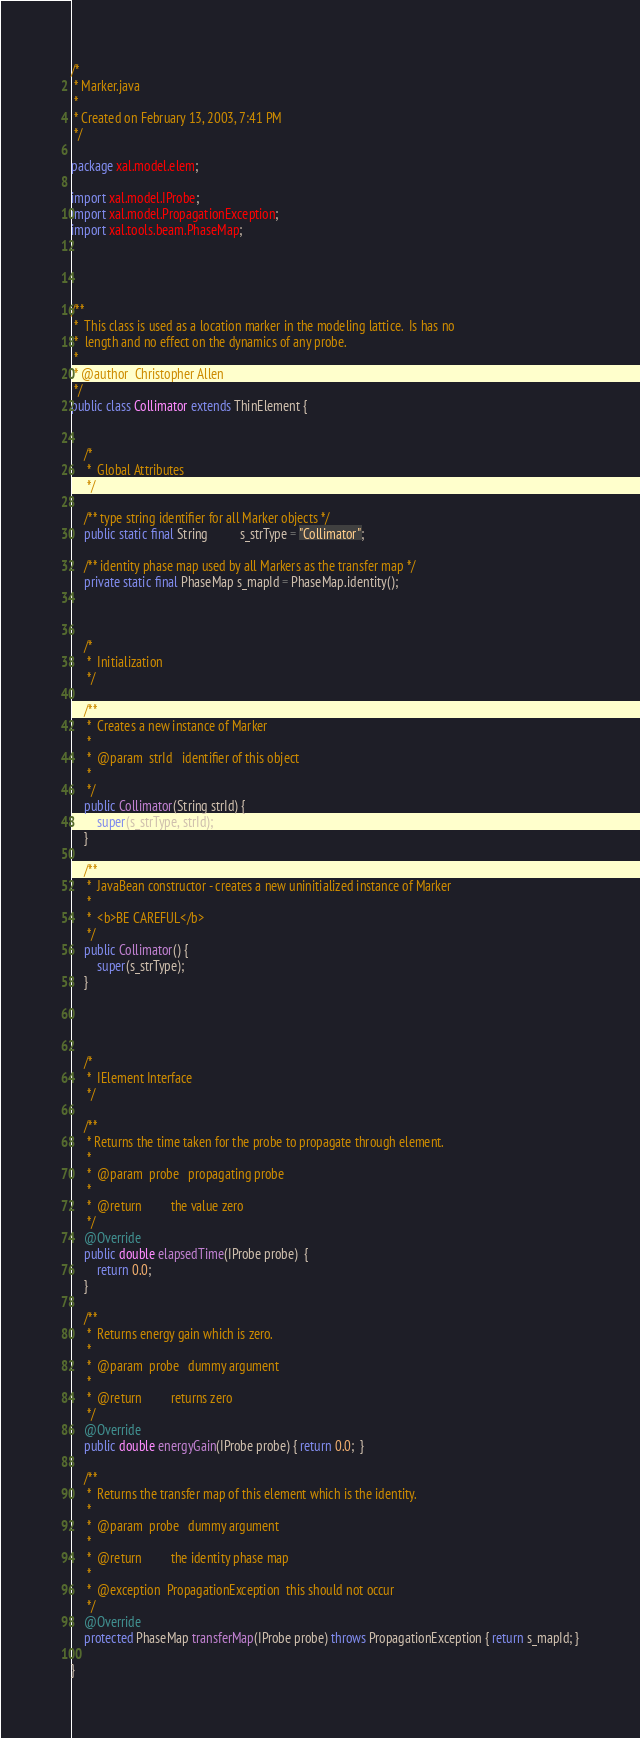<code> <loc_0><loc_0><loc_500><loc_500><_Java_>/*
 * Marker.java
 *
 * Created on February 13, 2003, 7:41 PM
 */

package xal.model.elem;

import xal.model.IProbe;
import xal.model.PropagationException;
import xal.tools.beam.PhaseMap;




/**
 *  This class is used as a location marker in the modeling lattice.  Is has no
 *  length and no effect on the dynamics of any probe.
 *
 * @author  Christopher Allen
 */
public class Collimator extends ThinElement {
    
    
    /*
     *  Global Attributes
     */
    
    /** type string identifier for all Marker objects */
    public static final String          s_strType = "Collimator";
    
    /** identity phase map used by all Markers as the transfer map */
    private static final PhaseMap s_mapId = PhaseMap.identity();
    
    

    /*
     *  Initialization
     */
    
    /** 
     *  Creates a new instance of Marker 
     *
     *  @param  strId   identifier of this object
     *
     */
    public Collimator(String strId) {
        super(s_strType, strId);
    }
    
    /** 
     *  JavaBean constructor - creates a new uninitialized instance of Marker
     *
     *  <b>BE CAREFUL</b>
     */
    public Collimator() {
        super(s_strType);
    }

    
    
    
    /*
     *  IElement Interface
     */
    
    /**
     * Returns the time taken for the probe to propagate through element.
     * 
     *  @param  probe   propagating probe
     *  
     *  @return         the value zero 
     */
    @Override
    public double elapsedTime(IProbe probe)  {
        return 0.0;
    }
    
    /**
     *  Returns energy gain which is zero.
     *
     *  @param  probe   dummy argument
     *
     *  @return         returns zero
     */
    @Override
    public double energyGain(IProbe probe) { return 0.0;  }
    
    /**  
     *  Returns the transfer map of this element which is the identity.
     *
     *  @param  probe   dummy argument
     *
     *  @return         the identity phase map
     *
     *  @exception  PropagationException  this should not occur
     */
    @Override
    protected PhaseMap transferMap(IProbe probe) throws PropagationException { return s_mapId; }
    
}</code> 